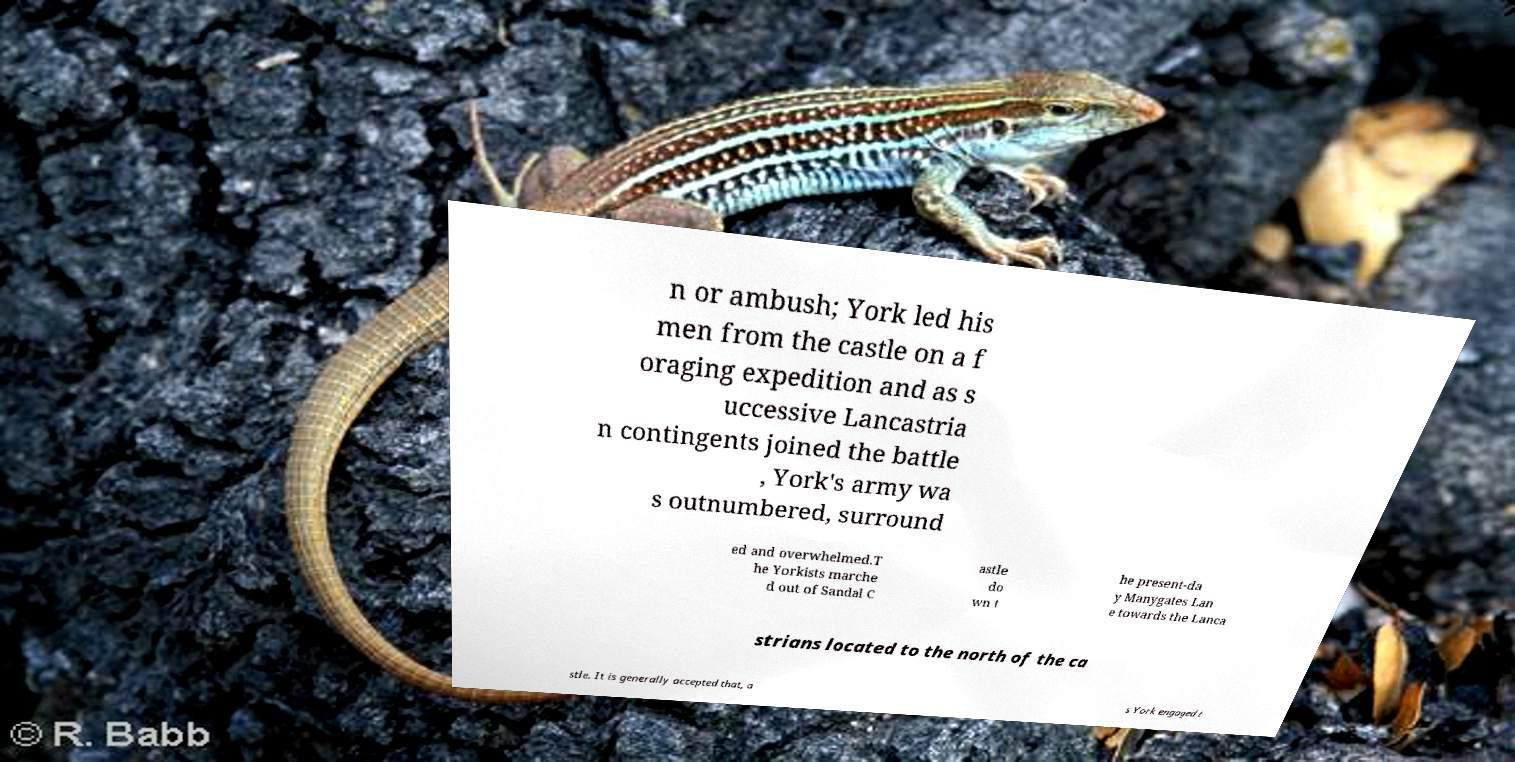Please read and relay the text visible in this image. What does it say? n or ambush; York led his men from the castle on a f oraging expedition and as s uccessive Lancastria n contingents joined the battle , York's army wa s outnumbered, surround ed and overwhelmed.T he Yorkists marche d out of Sandal C astle do wn t he present-da y Manygates Lan e towards the Lanca strians located to the north of the ca stle. It is generally accepted that, a s York engaged t 